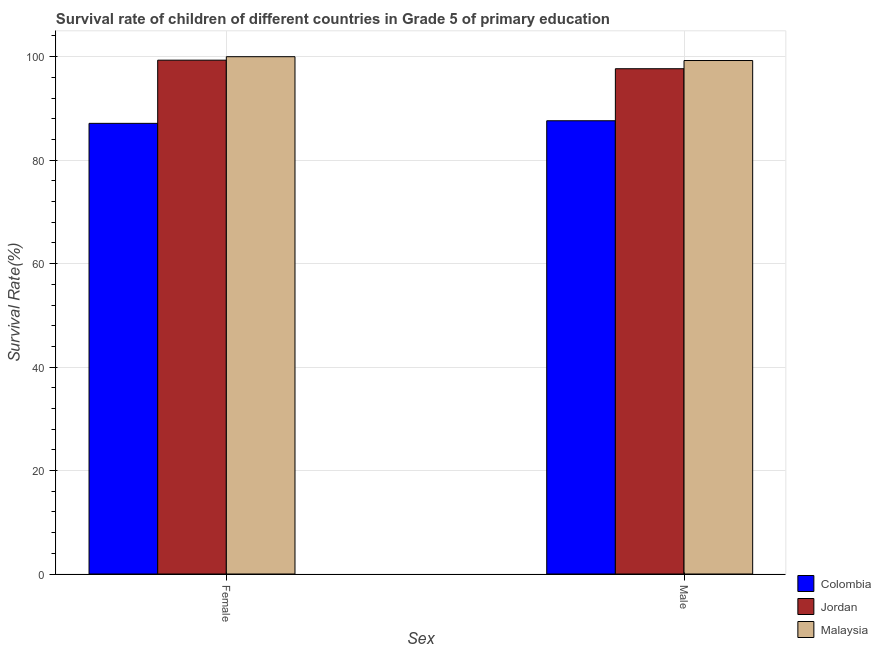How many bars are there on the 1st tick from the left?
Give a very brief answer. 3. What is the survival rate of male students in primary education in Jordan?
Ensure brevity in your answer.  97.67. Across all countries, what is the maximum survival rate of female students in primary education?
Offer a terse response. 100. Across all countries, what is the minimum survival rate of female students in primary education?
Offer a terse response. 87.11. In which country was the survival rate of female students in primary education maximum?
Make the answer very short. Malaysia. In which country was the survival rate of male students in primary education minimum?
Offer a terse response. Colombia. What is the total survival rate of male students in primary education in the graph?
Ensure brevity in your answer.  284.55. What is the difference between the survival rate of female students in primary education in Malaysia and that in Colombia?
Make the answer very short. 12.89. What is the difference between the survival rate of female students in primary education in Jordan and the survival rate of male students in primary education in Malaysia?
Offer a terse response. 0.07. What is the average survival rate of female students in primary education per country?
Provide a short and direct response. 95.48. What is the difference between the survival rate of female students in primary education and survival rate of male students in primary education in Colombia?
Provide a succinct answer. -0.5. In how many countries, is the survival rate of male students in primary education greater than 16 %?
Offer a terse response. 3. What is the ratio of the survival rate of female students in primary education in Colombia to that in Jordan?
Ensure brevity in your answer.  0.88. Is the survival rate of male students in primary education in Jordan less than that in Colombia?
Provide a succinct answer. No. In how many countries, is the survival rate of female students in primary education greater than the average survival rate of female students in primary education taken over all countries?
Your answer should be compact. 2. What does the 2nd bar from the left in Male represents?
Your answer should be very brief. Jordan. What does the 2nd bar from the right in Male represents?
Your answer should be very brief. Jordan. How many bars are there?
Offer a terse response. 6. Are all the bars in the graph horizontal?
Offer a very short reply. No. Does the graph contain grids?
Your answer should be very brief. Yes. Where does the legend appear in the graph?
Provide a short and direct response. Bottom right. How are the legend labels stacked?
Give a very brief answer. Vertical. What is the title of the graph?
Your response must be concise. Survival rate of children of different countries in Grade 5 of primary education. Does "Peru" appear as one of the legend labels in the graph?
Offer a terse response. No. What is the label or title of the X-axis?
Provide a short and direct response. Sex. What is the label or title of the Y-axis?
Offer a very short reply. Survival Rate(%). What is the Survival Rate(%) of Colombia in Female?
Provide a short and direct response. 87.11. What is the Survival Rate(%) of Jordan in Female?
Your answer should be compact. 99.33. What is the Survival Rate(%) of Colombia in Male?
Keep it short and to the point. 87.62. What is the Survival Rate(%) in Jordan in Male?
Keep it short and to the point. 97.67. What is the Survival Rate(%) of Malaysia in Male?
Provide a short and direct response. 99.26. Across all Sex, what is the maximum Survival Rate(%) of Colombia?
Your response must be concise. 87.62. Across all Sex, what is the maximum Survival Rate(%) of Jordan?
Keep it short and to the point. 99.33. Across all Sex, what is the maximum Survival Rate(%) of Malaysia?
Offer a terse response. 100. Across all Sex, what is the minimum Survival Rate(%) in Colombia?
Your answer should be very brief. 87.11. Across all Sex, what is the minimum Survival Rate(%) in Jordan?
Your answer should be very brief. 97.67. Across all Sex, what is the minimum Survival Rate(%) of Malaysia?
Your response must be concise. 99.26. What is the total Survival Rate(%) in Colombia in the graph?
Your answer should be very brief. 174.73. What is the total Survival Rate(%) of Jordan in the graph?
Your answer should be compact. 197. What is the total Survival Rate(%) in Malaysia in the graph?
Offer a terse response. 199.26. What is the difference between the Survival Rate(%) of Colombia in Female and that in Male?
Your answer should be very brief. -0.5. What is the difference between the Survival Rate(%) in Jordan in Female and that in Male?
Provide a short and direct response. 1.65. What is the difference between the Survival Rate(%) of Malaysia in Female and that in Male?
Make the answer very short. 0.74. What is the difference between the Survival Rate(%) in Colombia in Female and the Survival Rate(%) in Jordan in Male?
Offer a very short reply. -10.56. What is the difference between the Survival Rate(%) in Colombia in Female and the Survival Rate(%) in Malaysia in Male?
Keep it short and to the point. -12.15. What is the difference between the Survival Rate(%) of Jordan in Female and the Survival Rate(%) of Malaysia in Male?
Ensure brevity in your answer.  0.07. What is the average Survival Rate(%) in Colombia per Sex?
Your answer should be compact. 87.36. What is the average Survival Rate(%) in Jordan per Sex?
Keep it short and to the point. 98.5. What is the average Survival Rate(%) of Malaysia per Sex?
Offer a terse response. 99.63. What is the difference between the Survival Rate(%) in Colombia and Survival Rate(%) in Jordan in Female?
Make the answer very short. -12.21. What is the difference between the Survival Rate(%) in Colombia and Survival Rate(%) in Malaysia in Female?
Keep it short and to the point. -12.89. What is the difference between the Survival Rate(%) of Jordan and Survival Rate(%) of Malaysia in Female?
Offer a terse response. -0.67. What is the difference between the Survival Rate(%) of Colombia and Survival Rate(%) of Jordan in Male?
Keep it short and to the point. -10.06. What is the difference between the Survival Rate(%) of Colombia and Survival Rate(%) of Malaysia in Male?
Make the answer very short. -11.64. What is the difference between the Survival Rate(%) of Jordan and Survival Rate(%) of Malaysia in Male?
Give a very brief answer. -1.59. What is the ratio of the Survival Rate(%) in Jordan in Female to that in Male?
Keep it short and to the point. 1.02. What is the ratio of the Survival Rate(%) in Malaysia in Female to that in Male?
Give a very brief answer. 1.01. What is the difference between the highest and the second highest Survival Rate(%) in Colombia?
Give a very brief answer. 0.5. What is the difference between the highest and the second highest Survival Rate(%) in Jordan?
Ensure brevity in your answer.  1.65. What is the difference between the highest and the second highest Survival Rate(%) of Malaysia?
Offer a very short reply. 0.74. What is the difference between the highest and the lowest Survival Rate(%) in Colombia?
Offer a very short reply. 0.5. What is the difference between the highest and the lowest Survival Rate(%) in Jordan?
Your answer should be compact. 1.65. What is the difference between the highest and the lowest Survival Rate(%) in Malaysia?
Ensure brevity in your answer.  0.74. 